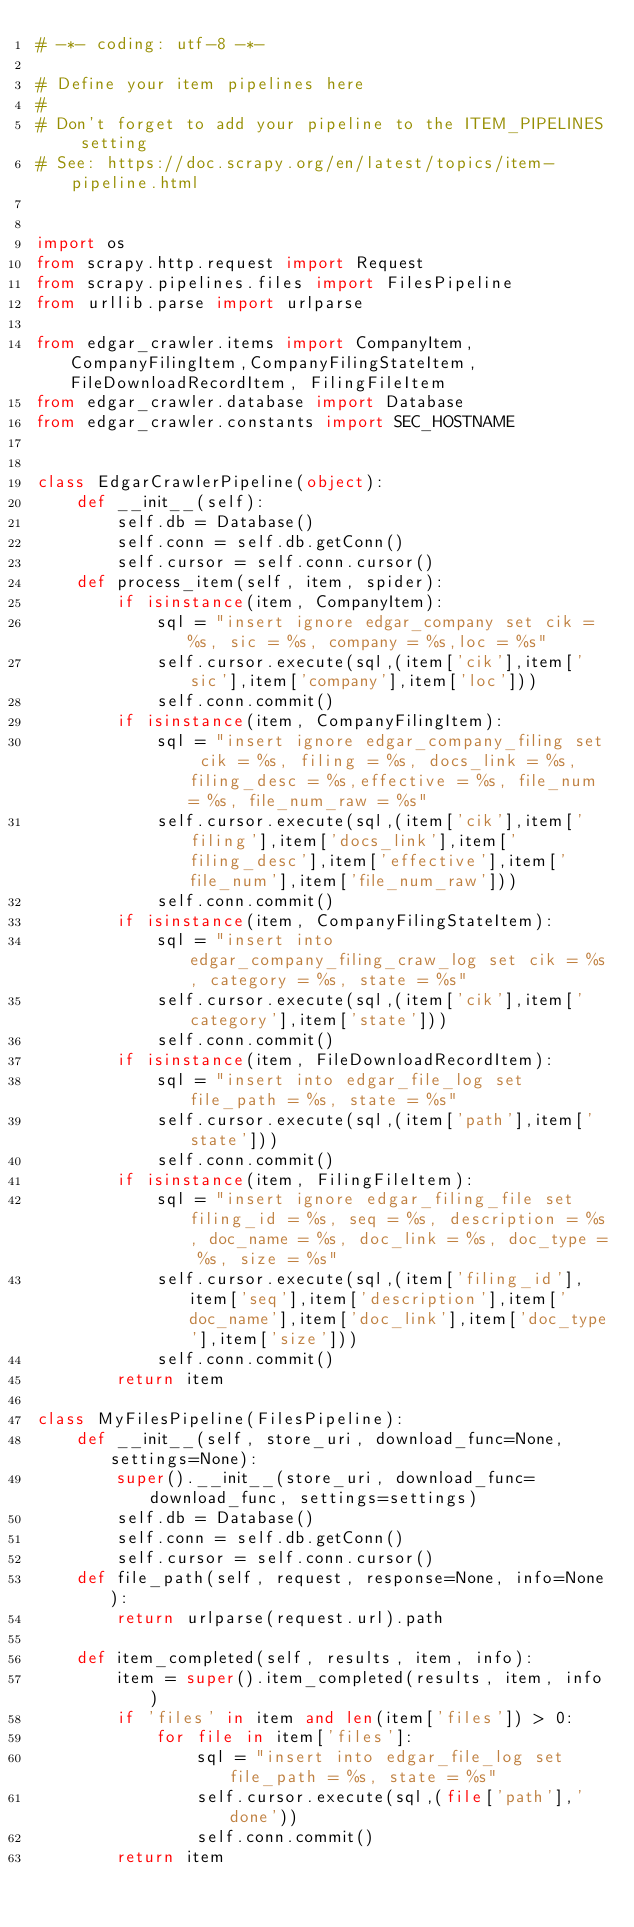<code> <loc_0><loc_0><loc_500><loc_500><_Python_># -*- coding: utf-8 -*-

# Define your item pipelines here
#
# Don't forget to add your pipeline to the ITEM_PIPELINES setting
# See: https://doc.scrapy.org/en/latest/topics/item-pipeline.html


import os
from scrapy.http.request import Request
from scrapy.pipelines.files import FilesPipeline
from urllib.parse import urlparse

from edgar_crawler.items import CompanyItem, CompanyFilingItem,CompanyFilingStateItem,FileDownloadRecordItem, FilingFileItem
from edgar_crawler.database import Database
from edgar_crawler.constants import SEC_HOSTNAME


class EdgarCrawlerPipeline(object):
    def __init__(self):
        self.db = Database()
        self.conn = self.db.getConn()
        self.cursor = self.conn.cursor()
    def process_item(self, item, spider):
        if isinstance(item, CompanyItem):
            sql = "insert ignore edgar_company set cik = %s, sic = %s, company = %s,loc = %s"
            self.cursor.execute(sql,(item['cik'],item['sic'],item['company'],item['loc']))
            self.conn.commit()
        if isinstance(item, CompanyFilingItem):
            sql = "insert ignore edgar_company_filing set cik = %s, filing = %s, docs_link = %s,filing_desc = %s,effective = %s, file_num = %s, file_num_raw = %s"
            self.cursor.execute(sql,(item['cik'],item['filing'],item['docs_link'],item['filing_desc'],item['effective'],item['file_num'],item['file_num_raw']))
            self.conn.commit()
        if isinstance(item, CompanyFilingStateItem):
            sql = "insert into edgar_company_filing_craw_log set cik = %s, category = %s, state = %s"
            self.cursor.execute(sql,(item['cik'],item['category'],item['state']))
            self.conn.commit()
        if isinstance(item, FileDownloadRecordItem):
            sql = "insert into edgar_file_log set file_path = %s, state = %s"
            self.cursor.execute(sql,(item['path'],item['state']))
            self.conn.commit()
        if isinstance(item, FilingFileItem):
            sql = "insert ignore edgar_filing_file set filing_id = %s, seq = %s, description = %s, doc_name = %s, doc_link = %s, doc_type = %s, size = %s"
            self.cursor.execute(sql,(item['filing_id'],item['seq'],item['description'],item['doc_name'],item['doc_link'],item['doc_type'],item['size']))
            self.conn.commit()
        return item

class MyFilesPipeline(FilesPipeline):
    def __init__(self, store_uri, download_func=None, settings=None):
        super().__init__(store_uri, download_func=download_func, settings=settings)
        self.db = Database()
        self.conn = self.db.getConn()
        self.cursor = self.conn.cursor()
    def file_path(self, request, response=None, info=None):
        return urlparse(request.url).path
        
    def item_completed(self, results, item, info):
        item = super().item_completed(results, item, info)
        if 'files' in item and len(item['files']) > 0:
            for file in item['files']:
                sql = "insert into edgar_file_log set file_path = %s, state = %s"
                self.cursor.execute(sql,(file['path'],'done'))
                self.conn.commit()
        return item</code> 